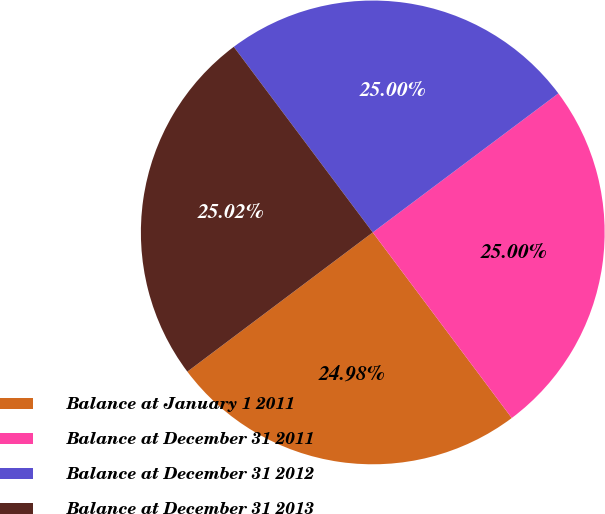<chart> <loc_0><loc_0><loc_500><loc_500><pie_chart><fcel>Balance at January 1 2011<fcel>Balance at December 31 2011<fcel>Balance at December 31 2012<fcel>Balance at December 31 2013<nl><fcel>24.98%<fcel>25.0%<fcel>25.0%<fcel>25.02%<nl></chart> 